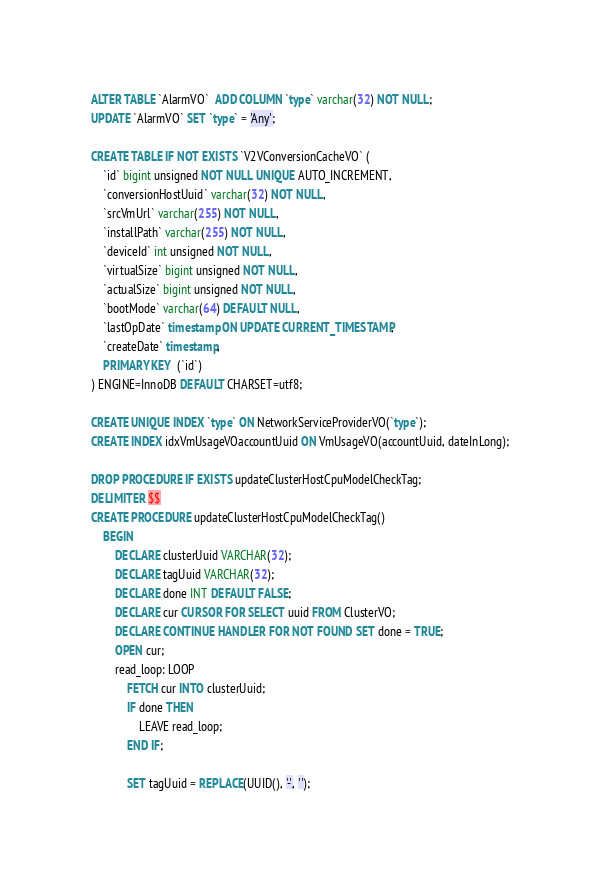<code> <loc_0><loc_0><loc_500><loc_500><_SQL_>ALTER TABLE `AlarmVO`  ADD COLUMN `type` varchar(32) NOT NULL;
UPDATE `AlarmVO` SET `type` = 'Any';

CREATE TABLE IF NOT EXISTS `V2VConversionCacheVO` (
    `id` bigint unsigned NOT NULL UNIQUE AUTO_INCREMENT,
    `conversionHostUuid` varchar(32) NOT NULL,
    `srcVmUrl` varchar(255) NOT NULL,
    `installPath` varchar(255) NOT NULL,
    `deviceId` int unsigned NOT NULL,
    `virtualSize` bigint unsigned NOT NULL,
    `actualSize` bigint unsigned NOT NULL,
    `bootMode` varchar(64) DEFAULT NULL,
    `lastOpDate` timestamp ON UPDATE CURRENT_TIMESTAMP,
    `createDate` timestamp,
    PRIMARY KEY  (`id`)
) ENGINE=InnoDB DEFAULT CHARSET=utf8;

CREATE UNIQUE INDEX `type` ON NetworkServiceProviderVO(`type`);
CREATE INDEX idxVmUsageVOaccountUuid ON VmUsageVO(accountUuid, dateInLong);

DROP PROCEDURE IF EXISTS updateClusterHostCpuModelCheckTag;
DELIMITER $$
CREATE PROCEDURE updateClusterHostCpuModelCheckTag()
    BEGIN
        DECLARE clusterUuid VARCHAR(32);
        DECLARE tagUuid VARCHAR(32);
        DECLARE done INT DEFAULT FALSE;
        DECLARE cur CURSOR FOR SELECT uuid FROM ClusterVO;
        DECLARE CONTINUE HANDLER FOR NOT FOUND SET done = TRUE;
        OPEN cur;
        read_loop: LOOP
            FETCH cur INTO clusterUuid;
            IF done THEN
                LEAVE read_loop;
            END IF;

            SET tagUuid = REPLACE(UUID(), '-', '');
</code> 